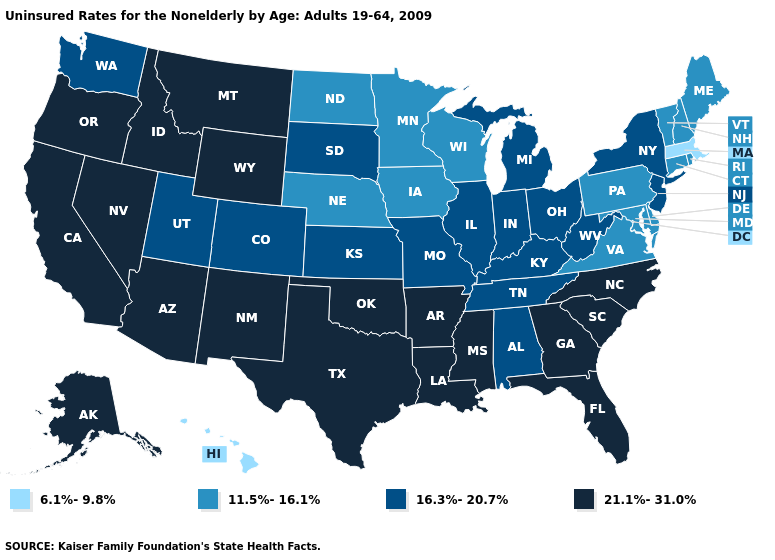Which states have the highest value in the USA?
Give a very brief answer. Alaska, Arizona, Arkansas, California, Florida, Georgia, Idaho, Louisiana, Mississippi, Montana, Nevada, New Mexico, North Carolina, Oklahoma, Oregon, South Carolina, Texas, Wyoming. What is the highest value in the USA?
Concise answer only. 21.1%-31.0%. Which states have the lowest value in the South?
Give a very brief answer. Delaware, Maryland, Virginia. What is the value of Ohio?
Quick response, please. 16.3%-20.7%. Name the states that have a value in the range 16.3%-20.7%?
Short answer required. Alabama, Colorado, Illinois, Indiana, Kansas, Kentucky, Michigan, Missouri, New Jersey, New York, Ohio, South Dakota, Tennessee, Utah, Washington, West Virginia. Among the states that border Wyoming , does Nebraska have the lowest value?
Be succinct. Yes. Name the states that have a value in the range 6.1%-9.8%?
Answer briefly. Hawaii, Massachusetts. What is the lowest value in the South?
Keep it brief. 11.5%-16.1%. Does Massachusetts have the lowest value in the USA?
Be succinct. Yes. Name the states that have a value in the range 11.5%-16.1%?
Give a very brief answer. Connecticut, Delaware, Iowa, Maine, Maryland, Minnesota, Nebraska, New Hampshire, North Dakota, Pennsylvania, Rhode Island, Vermont, Virginia, Wisconsin. What is the value of Montana?
Concise answer only. 21.1%-31.0%. Does Arkansas have the highest value in the USA?
Quick response, please. Yes. Among the states that border Tennessee , does Alabama have the highest value?
Keep it brief. No. Does the first symbol in the legend represent the smallest category?
Keep it brief. Yes. Does California have the lowest value in the USA?
Keep it brief. No. 